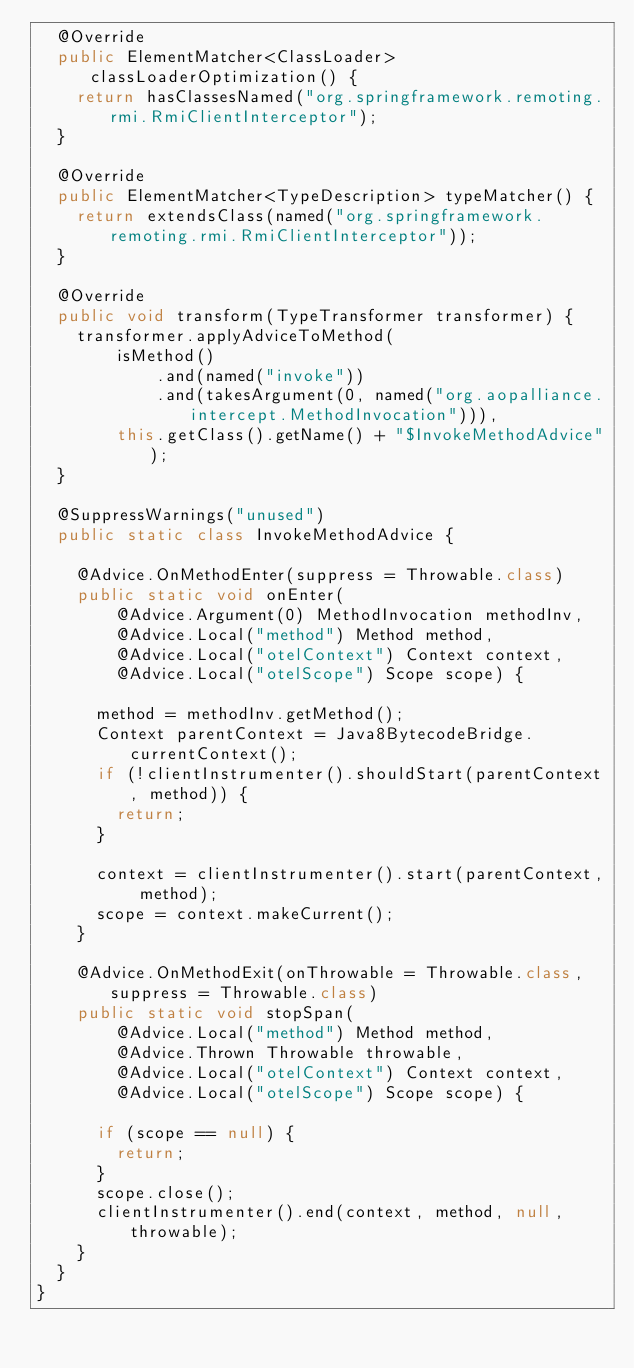<code> <loc_0><loc_0><loc_500><loc_500><_Java_>  @Override
  public ElementMatcher<ClassLoader> classLoaderOptimization() {
    return hasClassesNamed("org.springframework.remoting.rmi.RmiClientInterceptor");
  }

  @Override
  public ElementMatcher<TypeDescription> typeMatcher() {
    return extendsClass(named("org.springframework.remoting.rmi.RmiClientInterceptor"));
  }

  @Override
  public void transform(TypeTransformer transformer) {
    transformer.applyAdviceToMethod(
        isMethod()
            .and(named("invoke"))
            .and(takesArgument(0, named("org.aopalliance.intercept.MethodInvocation"))),
        this.getClass().getName() + "$InvokeMethodAdvice");
  }

  @SuppressWarnings("unused")
  public static class InvokeMethodAdvice {

    @Advice.OnMethodEnter(suppress = Throwable.class)
    public static void onEnter(
        @Advice.Argument(0) MethodInvocation methodInv,
        @Advice.Local("method") Method method,
        @Advice.Local("otelContext") Context context,
        @Advice.Local("otelScope") Scope scope) {

      method = methodInv.getMethod();
      Context parentContext = Java8BytecodeBridge.currentContext();
      if (!clientInstrumenter().shouldStart(parentContext, method)) {
        return;
      }

      context = clientInstrumenter().start(parentContext, method);
      scope = context.makeCurrent();
    }

    @Advice.OnMethodExit(onThrowable = Throwable.class, suppress = Throwable.class)
    public static void stopSpan(
        @Advice.Local("method") Method method,
        @Advice.Thrown Throwable throwable,
        @Advice.Local("otelContext") Context context,
        @Advice.Local("otelScope") Scope scope) {

      if (scope == null) {
        return;
      }
      scope.close();
      clientInstrumenter().end(context, method, null, throwable);
    }
  }
}
</code> 